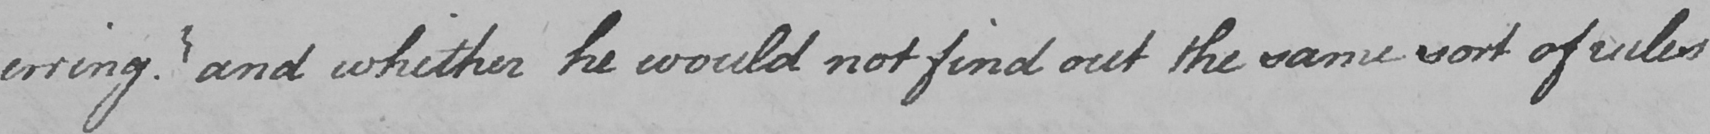Transcribe the text shown in this historical manuscript line. erring ?  and whither he would not find out the same sort of rules 